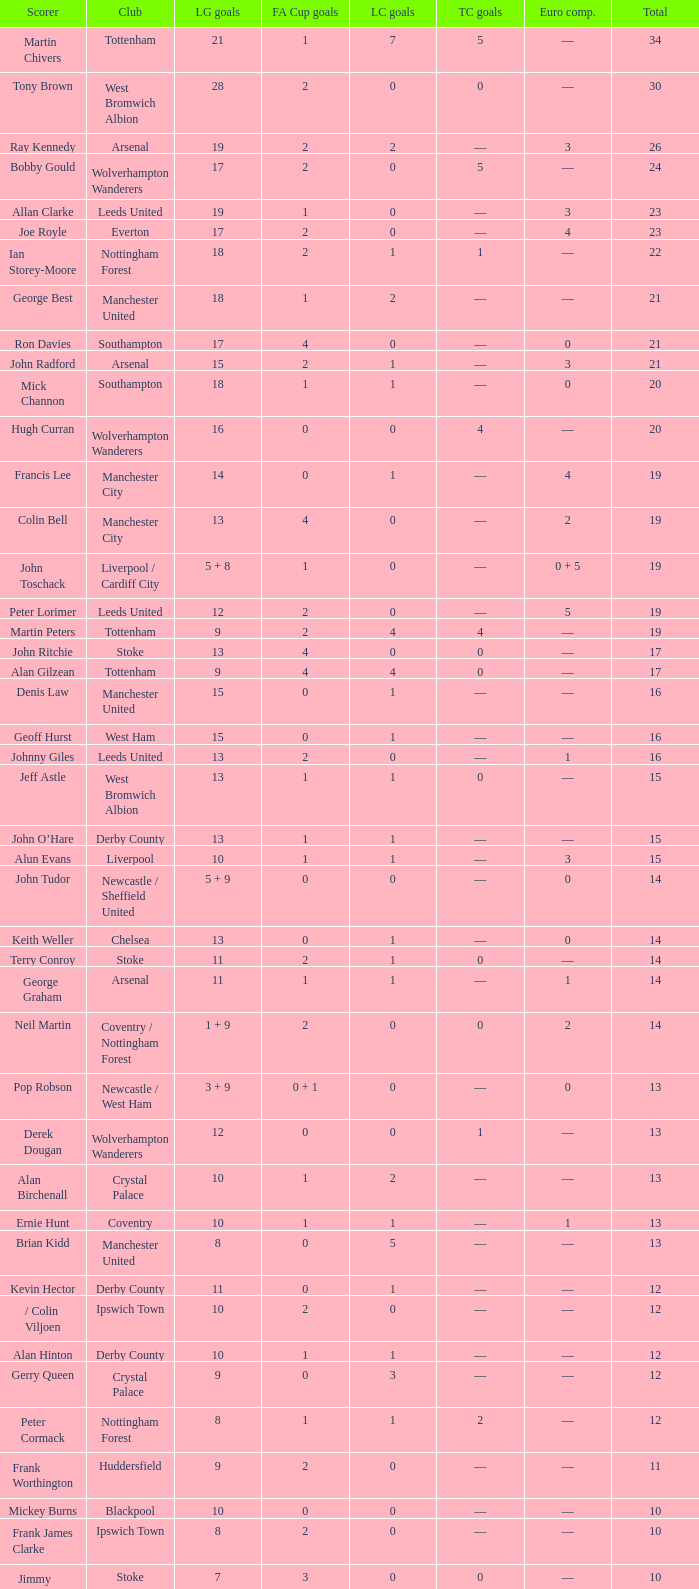What is the lowest League Cup Goals, when Scorer is Denis Law? 1.0. Parse the table in full. {'header': ['Scorer', 'Club', 'LG goals', 'FA Cup goals', 'LC goals', 'TC goals', 'Euro comp.', 'Total'], 'rows': [['Martin Chivers', 'Tottenham', '21', '1', '7', '5', '—', '34'], ['Tony Brown', 'West Bromwich Albion', '28', '2', '0', '0', '—', '30'], ['Ray Kennedy', 'Arsenal', '19', '2', '2', '—', '3', '26'], ['Bobby Gould', 'Wolverhampton Wanderers', '17', '2', '0', '5', '—', '24'], ['Allan Clarke', 'Leeds United', '19', '1', '0', '—', '3', '23'], ['Joe Royle', 'Everton', '17', '2', '0', '—', '4', '23'], ['Ian Storey-Moore', 'Nottingham Forest', '18', '2', '1', '1', '—', '22'], ['George Best', 'Manchester United', '18', '1', '2', '—', '—', '21'], ['Ron Davies', 'Southampton', '17', '4', '0', '—', '0', '21'], ['John Radford', 'Arsenal', '15', '2', '1', '—', '3', '21'], ['Mick Channon', 'Southampton', '18', '1', '1', '—', '0', '20'], ['Hugh Curran', 'Wolverhampton Wanderers', '16', '0', '0', '4', '—', '20'], ['Francis Lee', 'Manchester City', '14', '0', '1', '—', '4', '19'], ['Colin Bell', 'Manchester City', '13', '4', '0', '—', '2', '19'], ['John Toschack', 'Liverpool / Cardiff City', '5 + 8', '1', '0', '—', '0 + 5', '19'], ['Peter Lorimer', 'Leeds United', '12', '2', '0', '—', '5', '19'], ['Martin Peters', 'Tottenham', '9', '2', '4', '4', '—', '19'], ['John Ritchie', 'Stoke', '13', '4', '0', '0', '—', '17'], ['Alan Gilzean', 'Tottenham', '9', '4', '4', '0', '—', '17'], ['Denis Law', 'Manchester United', '15', '0', '1', '—', '—', '16'], ['Geoff Hurst', 'West Ham', '15', '0', '1', '—', '—', '16'], ['Johnny Giles', 'Leeds United', '13', '2', '0', '—', '1', '16'], ['Jeff Astle', 'West Bromwich Albion', '13', '1', '1', '0', '—', '15'], ['John O’Hare', 'Derby County', '13', '1', '1', '—', '—', '15'], ['Alun Evans', 'Liverpool', '10', '1', '1', '—', '3', '15'], ['John Tudor', 'Newcastle / Sheffield United', '5 + 9', '0', '0', '—', '0', '14'], ['Keith Weller', 'Chelsea', '13', '0', '1', '—', '0', '14'], ['Terry Conroy', 'Stoke', '11', '2', '1', '0', '—', '14'], ['George Graham', 'Arsenal', '11', '1', '1', '—', '1', '14'], ['Neil Martin', 'Coventry / Nottingham Forest', '1 + 9', '2', '0', '0', '2', '14'], ['Pop Robson', 'Newcastle / West Ham', '3 + 9', '0 + 1', '0', '—', '0', '13'], ['Derek Dougan', 'Wolverhampton Wanderers', '12', '0', '0', '1', '—', '13'], ['Alan Birchenall', 'Crystal Palace', '10', '1', '2', '—', '—', '13'], ['Ernie Hunt', 'Coventry', '10', '1', '1', '—', '1', '13'], ['Brian Kidd', 'Manchester United', '8', '0', '5', '—', '—', '13'], ['Kevin Hector', 'Derby County', '11', '0', '1', '—', '—', '12'], ['/ Colin Viljoen', 'Ipswich Town', '10', '2', '0', '—', '—', '12'], ['Alan Hinton', 'Derby County', '10', '1', '1', '—', '—', '12'], ['Gerry Queen', 'Crystal Palace', '9', '0', '3', '—', '—', '12'], ['Peter Cormack', 'Nottingham Forest', '8', '1', '1', '2', '—', '12'], ['Frank Worthington', 'Huddersfield', '9', '2', '0', '—', '—', '11'], ['Mickey Burns', 'Blackpool', '10', '0', '0', '—', '—', '10'], ['Frank James Clarke', 'Ipswich Town', '8', '2', '0', '—', '—', '10'], ['Jimmy Greenhoff', 'Stoke', '7', '3', '0', '0', '—', '10'], ['Charlie George', 'Arsenal', '5', '5', '0', '—', '0', '10']]} 